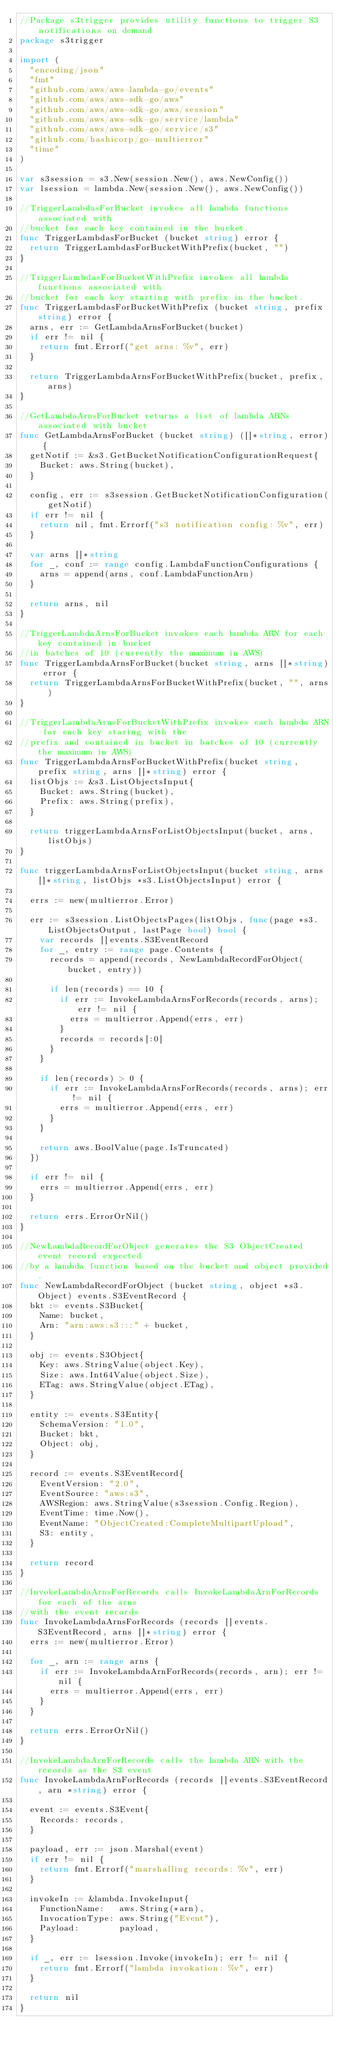<code> <loc_0><loc_0><loc_500><loc_500><_Go_>//Package s3trigger provides utility functions to trigger S3 notifications on demand
package s3trigger

import (
	"encoding/json"
	"fmt"
	"github.com/aws/aws-lambda-go/events"
	"github.com/aws/aws-sdk-go/aws"
	"github.com/aws/aws-sdk-go/aws/session"
	"github.com/aws/aws-sdk-go/service/lambda"
	"github.com/aws/aws-sdk-go/service/s3"
	"github.com/hashicorp/go-multierror"
	"time"
)

var s3session = s3.New(session.New(), aws.NewConfig())
var lsession = lambda.New(session.New(), aws.NewConfig())

//TriggerLambdasForBucket invokes all lambda functions associated with
//bucket for each key contained in the bucket.
func TriggerLambdasForBucket (bucket string) error {
	return TriggerLambdasForBucketWithPrefix(bucket, "")
}

//TriggerLambdasForBucketWithPrefix invokes all lambda functions associated with
//bucket for each key starting with prefix in the bucket.
func TriggerLambdasForBucketWithPrefix (bucket string, prefix string) error {
	arns, err := GetLambdaArnsForBucket(bucket)
	if err != nil {
		return fmt.Errorf("get arns: %v", err)
	}

	return TriggerLambdaArnsForBucketWithPrefix(bucket, prefix, arns)
}

//GetLambdaArnsForBucket returns a list of lambda ARNs associated with bucket
func GetLambdaArnsForBucket (bucket string) ([]*string, error) {
	getNotif := &s3.GetBucketNotificationConfigurationRequest{
		Bucket: aws.String(bucket),
	}

	config, err := s3session.GetBucketNotificationConfiguration(getNotif)
	if err != nil {
		return nil, fmt.Errorf("s3 notification config: %v", err)
	}

	var arns []*string
	for _, conf := range config.LambdaFunctionConfigurations {
		arns = append(arns, conf.LambdaFunctionArn)
	}

	return arns, nil
}

//TriggerLambdaArnsForBucket invokes each lambda ARN for each key contained in bucket
//in batches of 10 (currently the maximum in AWS)
func TriggerLambdaArnsForBucket(bucket string, arns []*string) error {
	return TriggerLambdaArnsForBucketWithPrefix(bucket, "", arns)
}

//TriggerLambdaArnsForBucketWithPrefix invokes each lambda ARN for each key staring with the
//prefix and contained in bucket in batches of 10 (currently the maximum in AWS)
func TriggerLambdaArnsForBucketWithPrefix(bucket string, prefix string, arns []*string) error {
	listObjs := &s3.ListObjectsInput{
		Bucket: aws.String(bucket),
		Prefix: aws.String(prefix),
	}

	return triggerLambdaArnsForListObjectsInput(bucket, arns, listObjs)
}

func triggerLambdaArnsForListObjectsInput(bucket string, arns []*string, listObjs *s3.ListObjectsInput) error {

	errs := new(multierror.Error)

	err := s3session.ListObjectsPages(listObjs, func(page *s3.ListObjectsOutput, lastPage bool) bool {
		var records []events.S3EventRecord
		for _, entry := range page.Contents {
			records = append(records, NewLambdaRecordForObject(bucket, entry))

			if len(records) == 10 {
				if err := InvokeLambdaArnsForRecords(records, arns); err != nil {
					errs = multierror.Append(errs, err)
				}
				records = records[:0]
			}
		}

		if len(records) > 0 {
			if err := InvokeLambdaArnsForRecords(records, arns); err != nil {
				errs = multierror.Append(errs, err)
			}
		}

		return aws.BoolValue(page.IsTruncated)
	})

	if err != nil {
		errs = multierror.Append(errs, err)
	}

	return errs.ErrorOrNil()
}

//NewLambdaRecordForObject generates the S3 ObjectCreated event record expected
//by a lambda function based on the bucket and object provided.
func NewLambdaRecordForObject (bucket string, object *s3.Object) events.S3EventRecord {
	bkt := events.S3Bucket{
		Name: bucket,
		Arn: "arn:aws:s3:::" + bucket,
	}

	obj := events.S3Object{
		Key: aws.StringValue(object.Key),
		Size: aws.Int64Value(object.Size),
		ETag: aws.StringValue(object.ETag),
	}

	entity := events.S3Entity{
		SchemaVersion: "1.0",
		Bucket: bkt,
		Object: obj,
	}

	record := events.S3EventRecord{
		EventVersion: "2.0",
		EventSource: "aws:s3",
		AWSRegion: aws.StringValue(s3session.Config.Region),
		EventTime: time.Now(),
		EventName: "ObjectCreated:CompleteMultipartUpload",
		S3: entity,
	}

	return record
}

//InvokeLambdaArnsForRecords calls InvokeLambdaArnForRecords for each of the arns
//with the event records
func InvokeLambdaArnsForRecords (records []events.S3EventRecord, arns []*string) error {
	errs := new(multierror.Error)

	for _, arn := range arns {
		if err := InvokeLambdaArnForRecords(records, arn); err != nil {
			errs = multierror.Append(errs, err)
		}
	}

	return errs.ErrorOrNil()
}

//InvokeLambdaArnForRecords calls the lambda ARN with the records as the S3 event
func InvokeLambdaArnForRecords (records []events.S3EventRecord, arn *string) error {

	event := events.S3Event{
		Records: records,
	}

	payload, err := json.Marshal(event)
	if err != nil {
		return fmt.Errorf("marshalling records: %v", err)
	}

	invokeIn := &lambda.InvokeInput{
		FunctionName:   aws.String(*arn),
		InvocationType: aws.String("Event"),
		Payload:        payload,
	}

	if _, err := lsession.Invoke(invokeIn); err != nil {
		return fmt.Errorf("lambda invokation: %v", err)
	}

	return nil
}</code> 